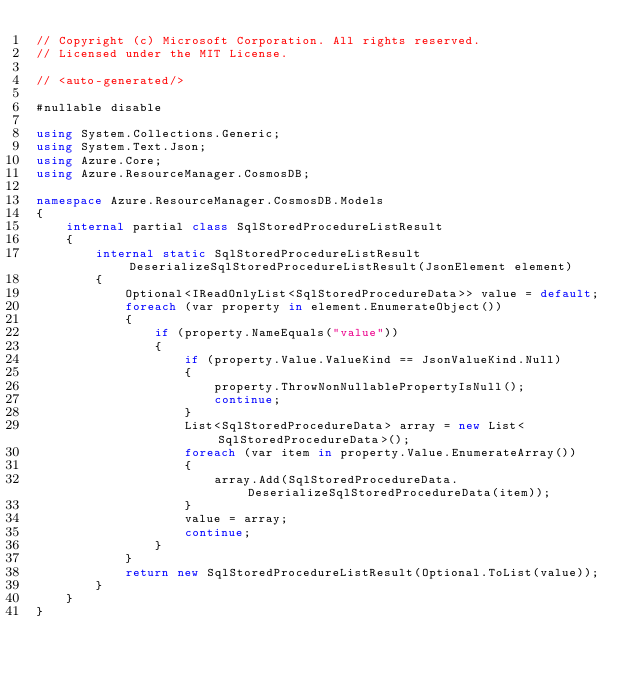<code> <loc_0><loc_0><loc_500><loc_500><_C#_>// Copyright (c) Microsoft Corporation. All rights reserved.
// Licensed under the MIT License.

// <auto-generated/>

#nullable disable

using System.Collections.Generic;
using System.Text.Json;
using Azure.Core;
using Azure.ResourceManager.CosmosDB;

namespace Azure.ResourceManager.CosmosDB.Models
{
    internal partial class SqlStoredProcedureListResult
    {
        internal static SqlStoredProcedureListResult DeserializeSqlStoredProcedureListResult(JsonElement element)
        {
            Optional<IReadOnlyList<SqlStoredProcedureData>> value = default;
            foreach (var property in element.EnumerateObject())
            {
                if (property.NameEquals("value"))
                {
                    if (property.Value.ValueKind == JsonValueKind.Null)
                    {
                        property.ThrowNonNullablePropertyIsNull();
                        continue;
                    }
                    List<SqlStoredProcedureData> array = new List<SqlStoredProcedureData>();
                    foreach (var item in property.Value.EnumerateArray())
                    {
                        array.Add(SqlStoredProcedureData.DeserializeSqlStoredProcedureData(item));
                    }
                    value = array;
                    continue;
                }
            }
            return new SqlStoredProcedureListResult(Optional.ToList(value));
        }
    }
}
</code> 